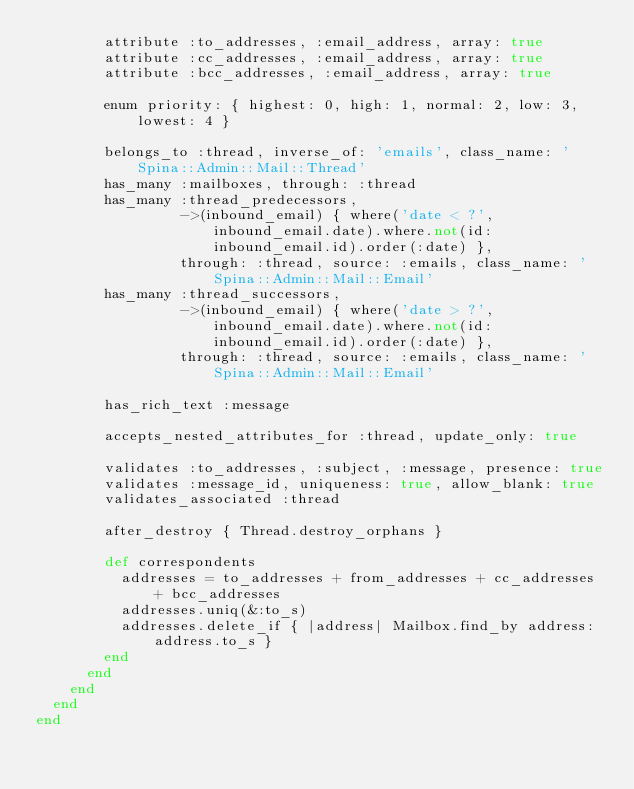Convert code to text. <code><loc_0><loc_0><loc_500><loc_500><_Ruby_>        attribute :to_addresses, :email_address, array: true
        attribute :cc_addresses, :email_address, array: true
        attribute :bcc_addresses, :email_address, array: true

        enum priority: { highest: 0, high: 1, normal: 2, low: 3, lowest: 4 }

        belongs_to :thread, inverse_of: 'emails', class_name: 'Spina::Admin::Mail::Thread'
        has_many :mailboxes, through: :thread
        has_many :thread_predecessors,
                 ->(inbound_email) { where('date < ?', inbound_email.date).where.not(id: inbound_email.id).order(:date) },
                 through: :thread, source: :emails, class_name: 'Spina::Admin::Mail::Email'
        has_many :thread_successors,
                 ->(inbound_email) { where('date > ?', inbound_email.date).where.not(id: inbound_email.id).order(:date) },
                 through: :thread, source: :emails, class_name: 'Spina::Admin::Mail::Email'

        has_rich_text :message

        accepts_nested_attributes_for :thread, update_only: true

        validates :to_addresses, :subject, :message, presence: true
        validates :message_id, uniqueness: true, allow_blank: true
        validates_associated :thread

        after_destroy { Thread.destroy_orphans }

        def correspondents
          addresses = to_addresses + from_addresses + cc_addresses + bcc_addresses
          addresses.uniq(&:to_s)
          addresses.delete_if { |address| Mailbox.find_by address: address.to_s }
        end
      end
    end
  end
end
</code> 